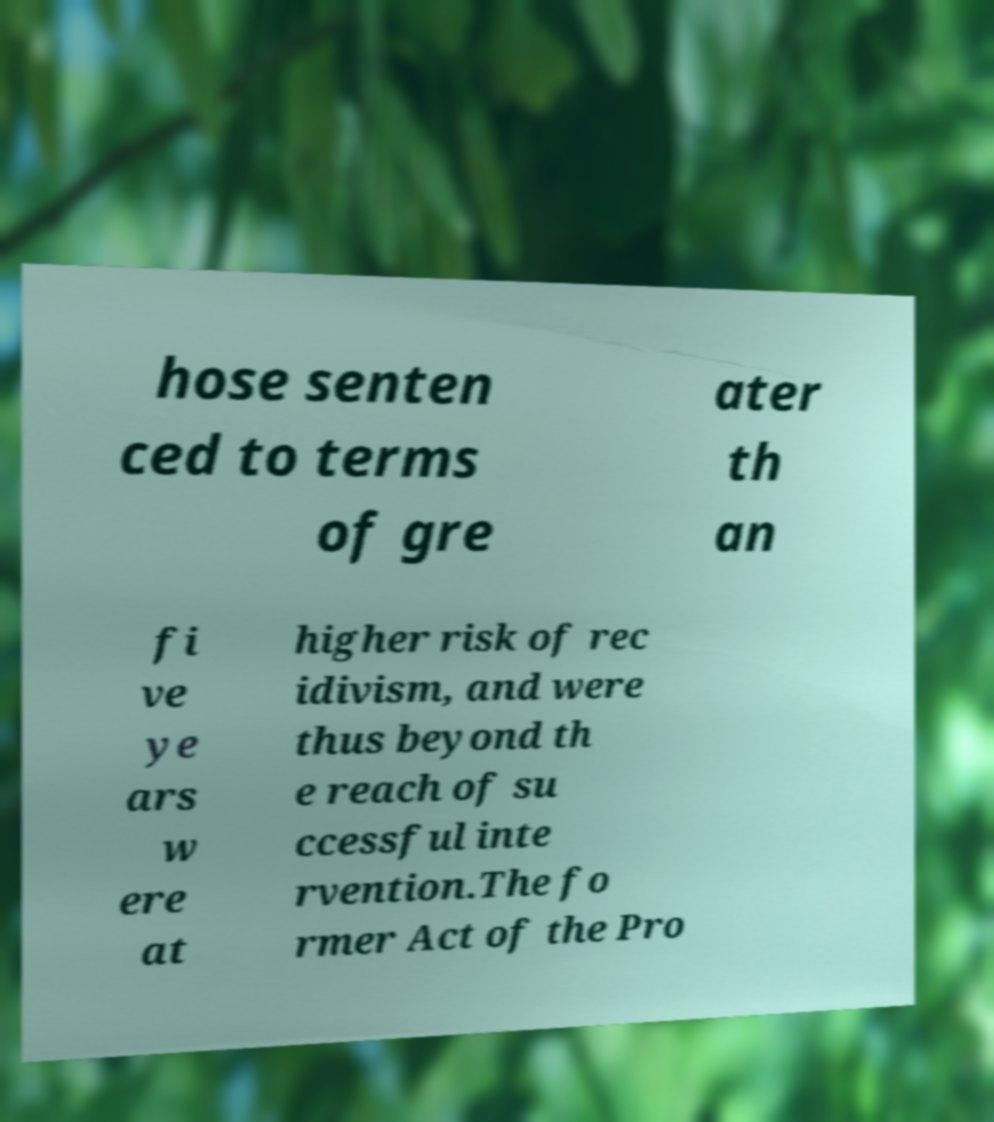Could you extract and type out the text from this image? hose senten ced to terms of gre ater th an fi ve ye ars w ere at higher risk of rec idivism, and were thus beyond th e reach of su ccessful inte rvention.The fo rmer Act of the Pro 